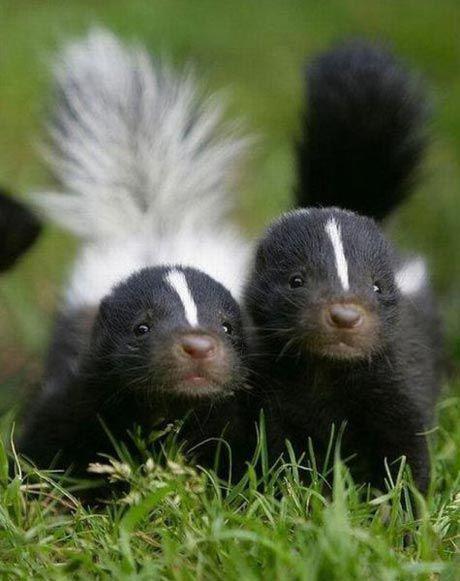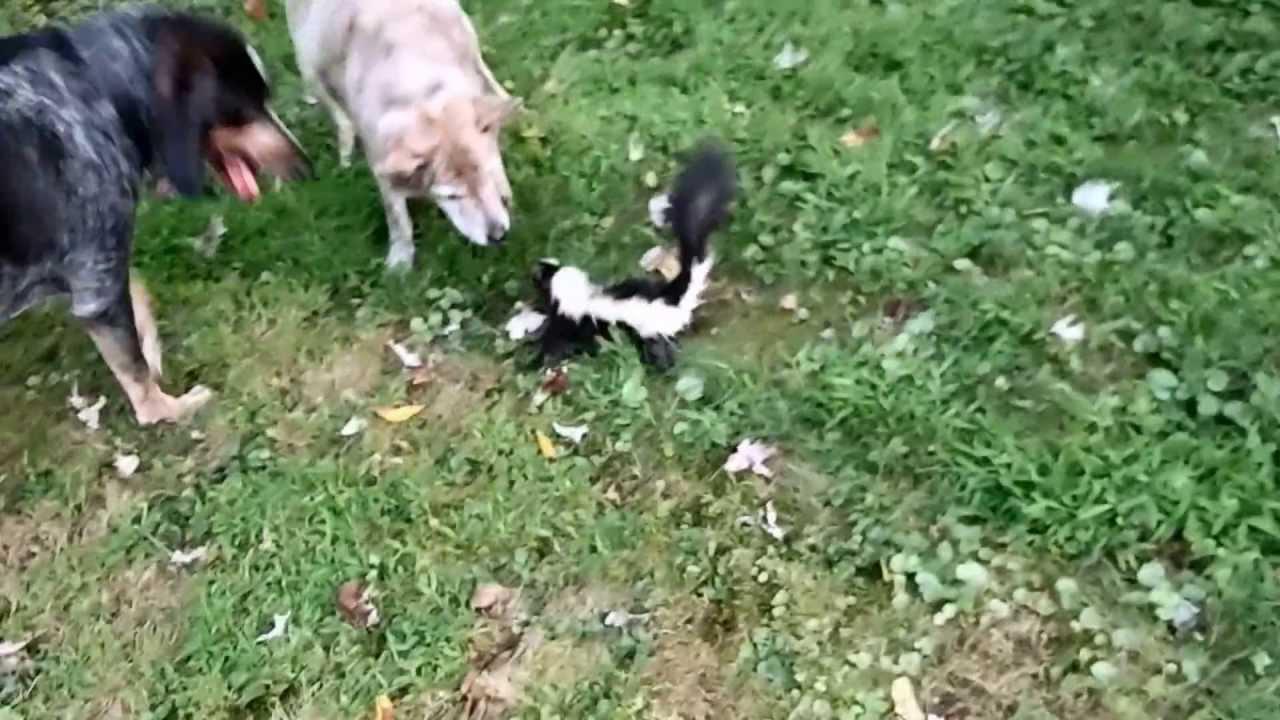The first image is the image on the left, the second image is the image on the right. For the images shown, is this caption "The combined images contain at least four skunks, including two side-by side with their faces pointing toward each other." true? Answer yes or no. No. The first image is the image on the left, the second image is the image on the right. Considering the images on both sides, is "Three or fewer mammals are visible." valid? Answer yes or no. No. 